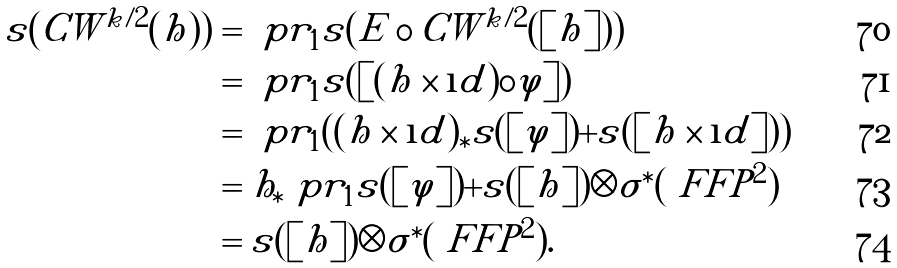<formula> <loc_0><loc_0><loc_500><loc_500>s ( C W ^ { k / 2 } ( h ) ) & = \ p r _ { 1 } s ( E \circ C W ^ { k / 2 } ( [ h ] ) ) \\ & = \ p r _ { 1 } s ( [ ( h \times \i d ) \circ \varphi ] ) \\ & = \ p r _ { 1 } ( ( h \times \i d ) _ { \ast } s ( [ \varphi ] ) + s ( [ h \times \i d ] ) ) \\ & = h _ { \ast } \ p r _ { 1 } s ( [ \varphi ] ) + s ( [ h ] ) \otimes \sigma ^ { \ast } ( \ F F P ^ { 2 } ) \\ & = s ( [ h ] ) \otimes \sigma ^ { \ast } ( \ F F P ^ { 2 } ) .</formula> 